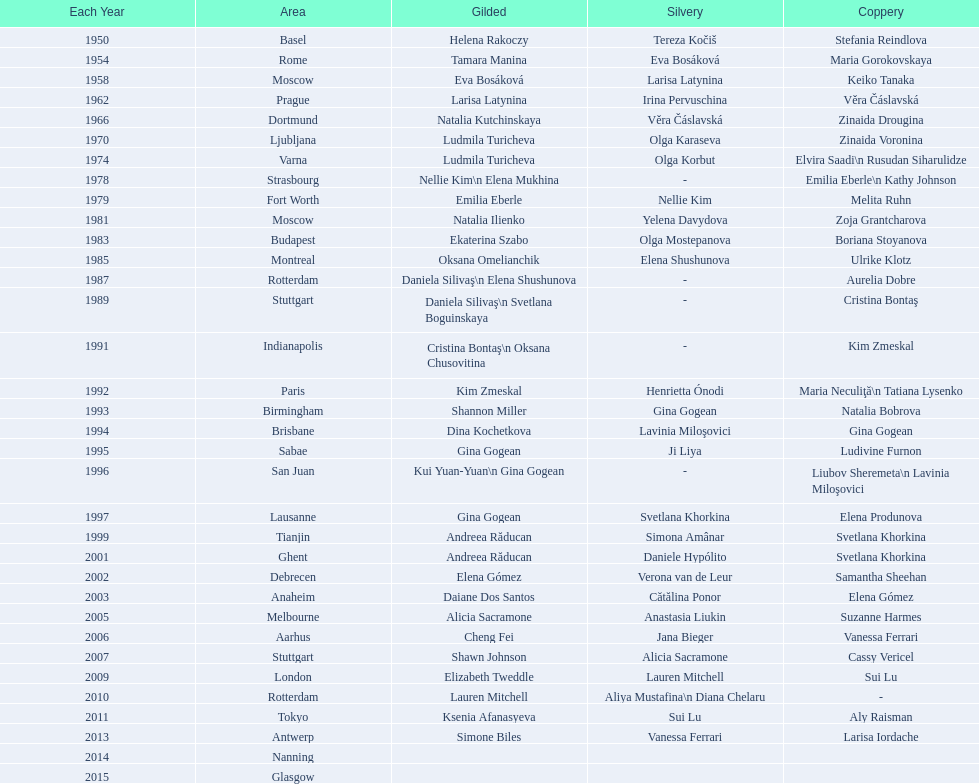What is the total number of russian gymnasts that have won silver. 8. 